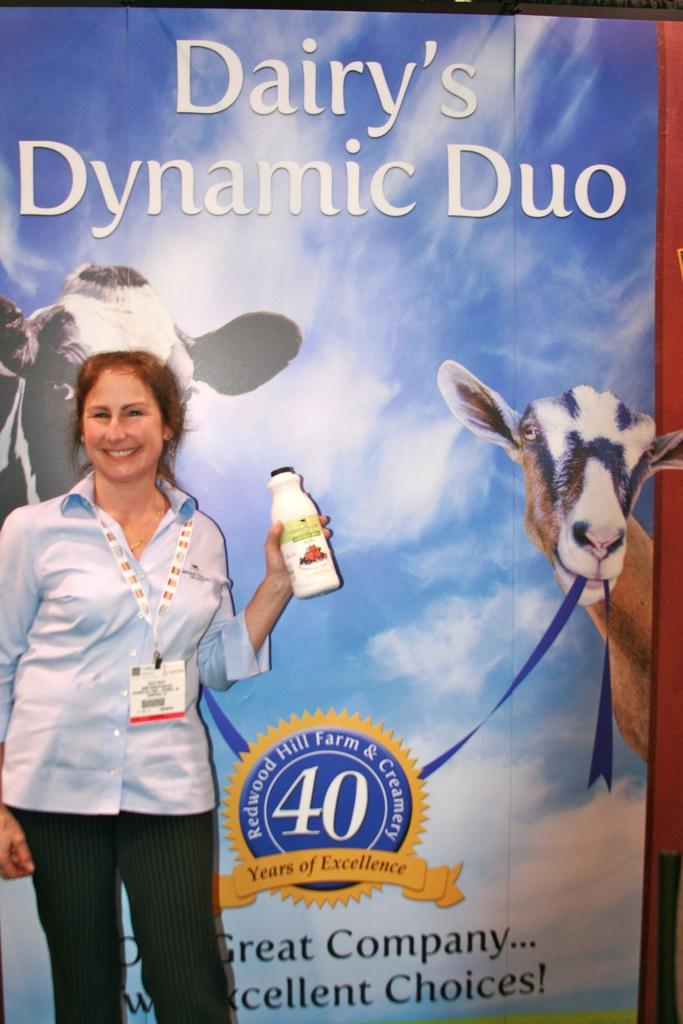Who is present in the image? There is a woman in the image. What is the woman wearing on her upper body? The woman is wearing a blue shirt. What is the woman wearing on her lower body? The woman is wearing black pants. What can be seen on the woman's chest? The woman is wearing an ID card. What is the woman's facial expression? The woman is smiling. What object is the woman holding in the image? The woman is holding a bottle. What type of cattle can be seen in the image? There are no cattle present in the image; it features a woman wearing a blue shirt, black pants, and an ID card, holding a bottle, and smiling. What is the woman discussing with the cattle in the image? There are no cattle present in the image, and therefore no discussion with cattle can be observed. 